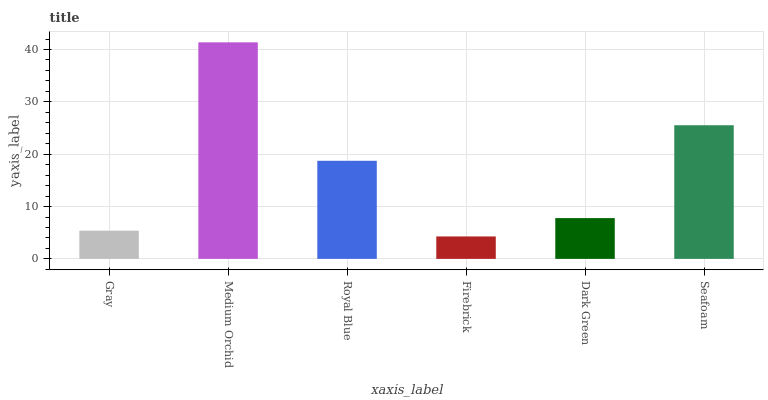Is Royal Blue the minimum?
Answer yes or no. No. Is Royal Blue the maximum?
Answer yes or no. No. Is Medium Orchid greater than Royal Blue?
Answer yes or no. Yes. Is Royal Blue less than Medium Orchid?
Answer yes or no. Yes. Is Royal Blue greater than Medium Orchid?
Answer yes or no. No. Is Medium Orchid less than Royal Blue?
Answer yes or no. No. Is Royal Blue the high median?
Answer yes or no. Yes. Is Dark Green the low median?
Answer yes or no. Yes. Is Medium Orchid the high median?
Answer yes or no. No. Is Seafoam the low median?
Answer yes or no. No. 